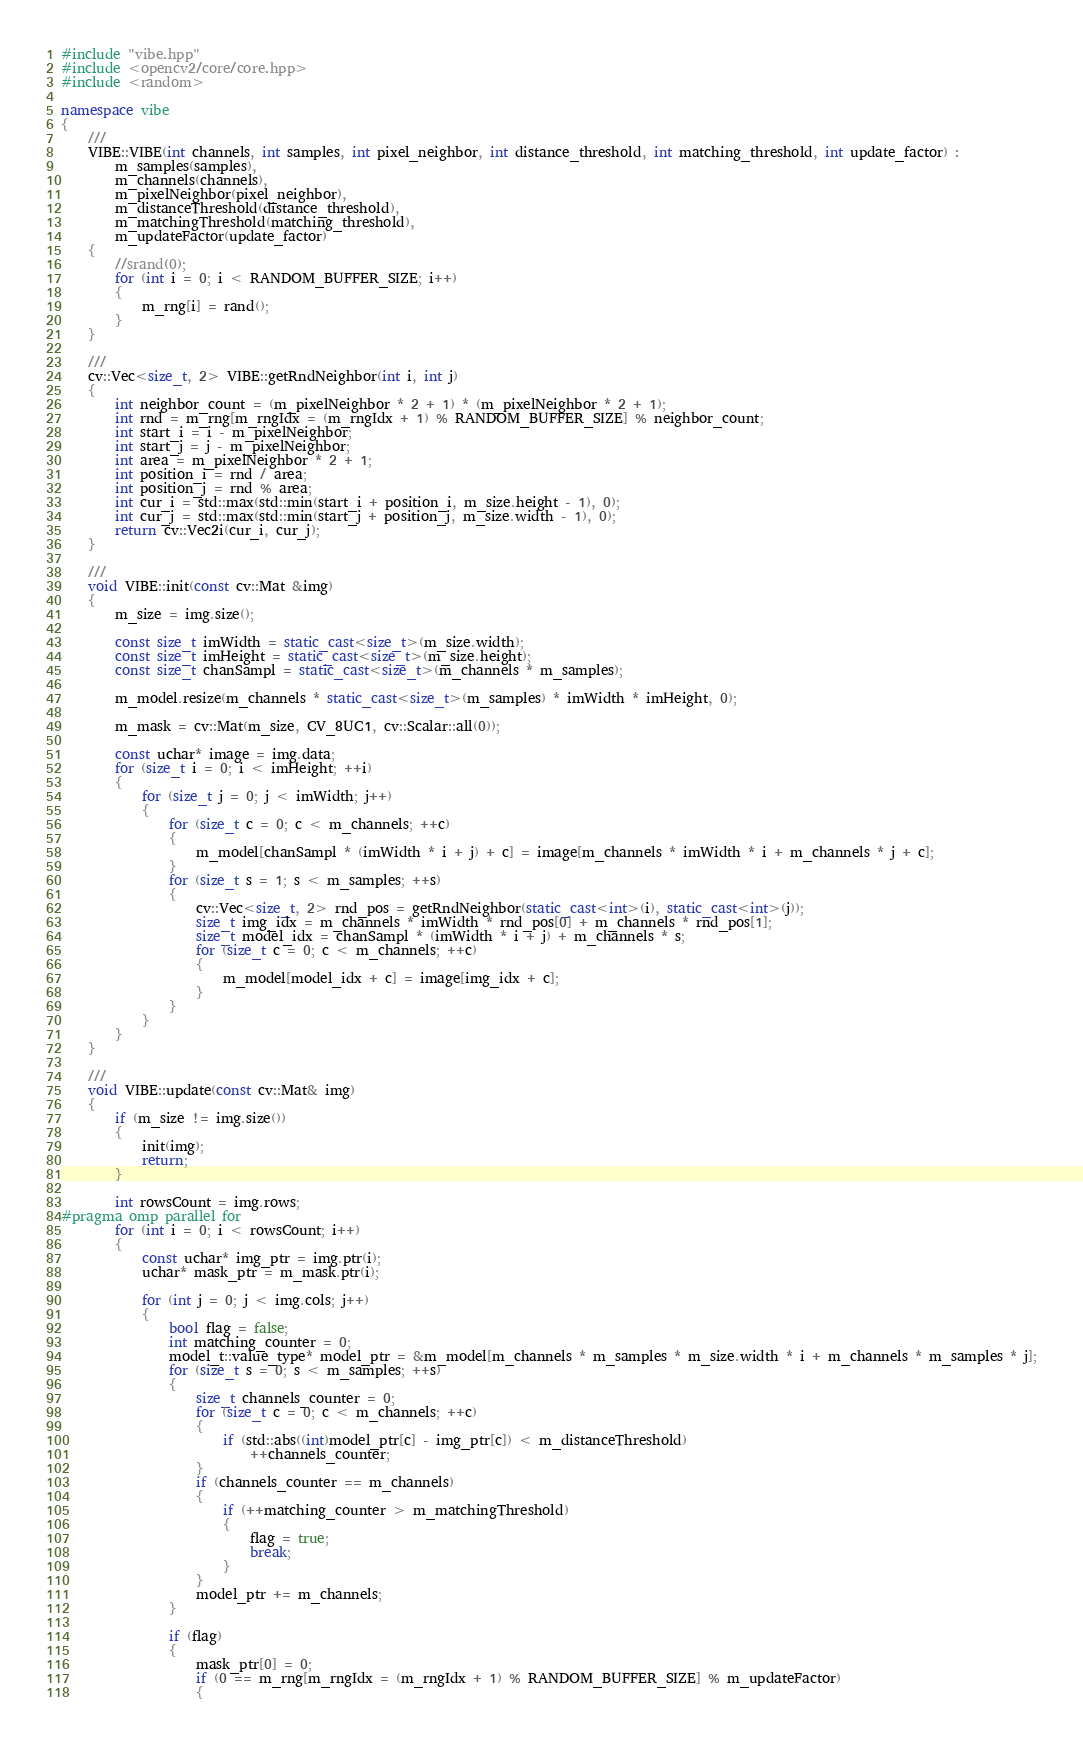<code> <loc_0><loc_0><loc_500><loc_500><_C++_>#include "vibe.hpp"
#include <opencv2/core/core.hpp>
#include <random>

namespace vibe
{
	///
	VIBE::VIBE(int channels, int samples, int pixel_neighbor, int distance_threshold, int matching_threshold, int update_factor) :
		m_samples(samples),
		m_channels(channels),
		m_pixelNeighbor(pixel_neighbor),
		m_distanceThreshold(distance_threshold),
		m_matchingThreshold(matching_threshold),
		m_updateFactor(update_factor)
	{
		//srand(0);
		for (int i = 0; i < RANDOM_BUFFER_SIZE; i++)
		{
			m_rng[i] = rand();
		}
	}

	///
	cv::Vec<size_t, 2> VIBE::getRndNeighbor(int i, int j)
	{
		int neighbor_count = (m_pixelNeighbor * 2 + 1) * (m_pixelNeighbor * 2 + 1);
		int rnd = m_rng[m_rngIdx = (m_rngIdx + 1) % RANDOM_BUFFER_SIZE] % neighbor_count;
		int start_i = i - m_pixelNeighbor;
		int start_j = j - m_pixelNeighbor;
		int area = m_pixelNeighbor * 2 + 1;
		int position_i = rnd / area;
		int position_j = rnd % area;
		int cur_i = std::max(std::min(start_i + position_i, m_size.height - 1), 0);
		int cur_j = std::max(std::min(start_j + position_j, m_size.width - 1), 0);
		return cv::Vec2i(cur_i, cur_j);
	}

	///
	void VIBE::init(const cv::Mat &img)
	{
		m_size = img.size();

		const size_t imWidth = static_cast<size_t>(m_size.width);
		const size_t imHeight = static_cast<size_t>(m_size.height);
		const size_t chanSampl = static_cast<size_t>(m_channels * m_samples);

		m_model.resize(m_channels * static_cast<size_t>(m_samples) * imWidth * imHeight, 0);

		m_mask = cv::Mat(m_size, CV_8UC1, cv::Scalar::all(0));

		const uchar* image = img.data;
		for (size_t i = 0; i < imHeight; ++i)
		{
			for (size_t j = 0; j < imWidth; j++)
			{
                for (size_t c = 0; c < m_channels; ++c)
				{
					m_model[chanSampl * (imWidth * i + j) + c] = image[m_channels * imWidth * i + m_channels * j + c];
				}
                for (size_t s = 1; s < m_samples; ++s)
				{
					cv::Vec<size_t, 2> rnd_pos = getRndNeighbor(static_cast<int>(i), static_cast<int>(j));
					size_t img_idx = m_channels * imWidth * rnd_pos[0] + m_channels * rnd_pos[1];
					size_t model_idx = chanSampl * (imWidth * i + j) + m_channels * s;
                    for (size_t c = 0; c < m_channels; ++c)
					{
						m_model[model_idx + c] = image[img_idx + c];
					}
				}
			}
		}
	}

	///
	void VIBE::update(const cv::Mat& img)
	{
		if (m_size != img.size())
		{
			init(img);
			return;
		}

		int rowsCount = img.rows;
#pragma omp parallel for
		for (int i = 0; i < rowsCount; i++)
		{
			const uchar* img_ptr = img.ptr(i);
			uchar* mask_ptr = m_mask.ptr(i);

			for (int j = 0; j < img.cols; j++)
			{
				bool flag = false;
				int matching_counter = 0;
				model_t::value_type* model_ptr = &m_model[m_channels * m_samples * m_size.width * i + m_channels * m_samples * j];
                for (size_t s = 0; s < m_samples; ++s)
				{
                    size_t channels_counter = 0;
                    for (size_t c = 0; c < m_channels; ++c)
					{
						if (std::abs((int)model_ptr[c] - img_ptr[c]) < m_distanceThreshold)
							++channels_counter;
					}
					if (channels_counter == m_channels)
					{
						if (++matching_counter > m_matchingThreshold)
						{
							flag = true;
							break;
						}
					}
					model_ptr += m_channels;
				}

				if (flag)
				{
					mask_ptr[0] = 0;
					if (0 == m_rng[m_rngIdx = (m_rngIdx + 1) % RANDOM_BUFFER_SIZE] % m_updateFactor)
					{</code> 